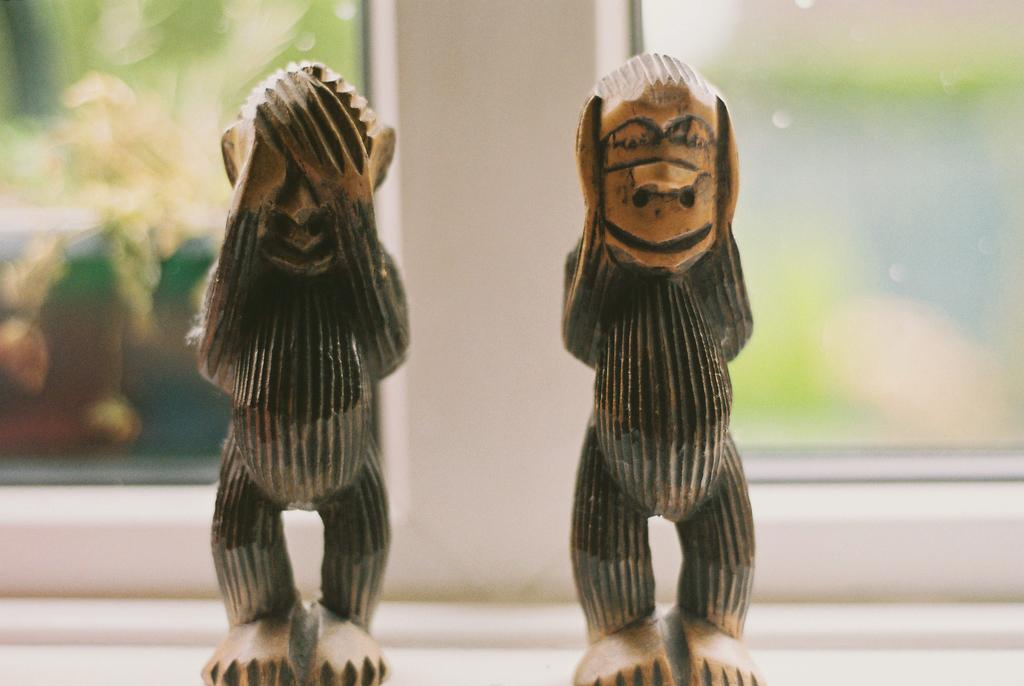What is the main subject of the image? The main subject of the image is toy statues. Where are the toy statues located in the image? The toy statues are in the center of the image. What can be seen in the background of the image? There are windows visible in the background of the image. What type of plastic material can be seen smashing the toy statues in the image? There is no plastic material smashing the toy statues in the image; the statues are stationary and undamaged. 